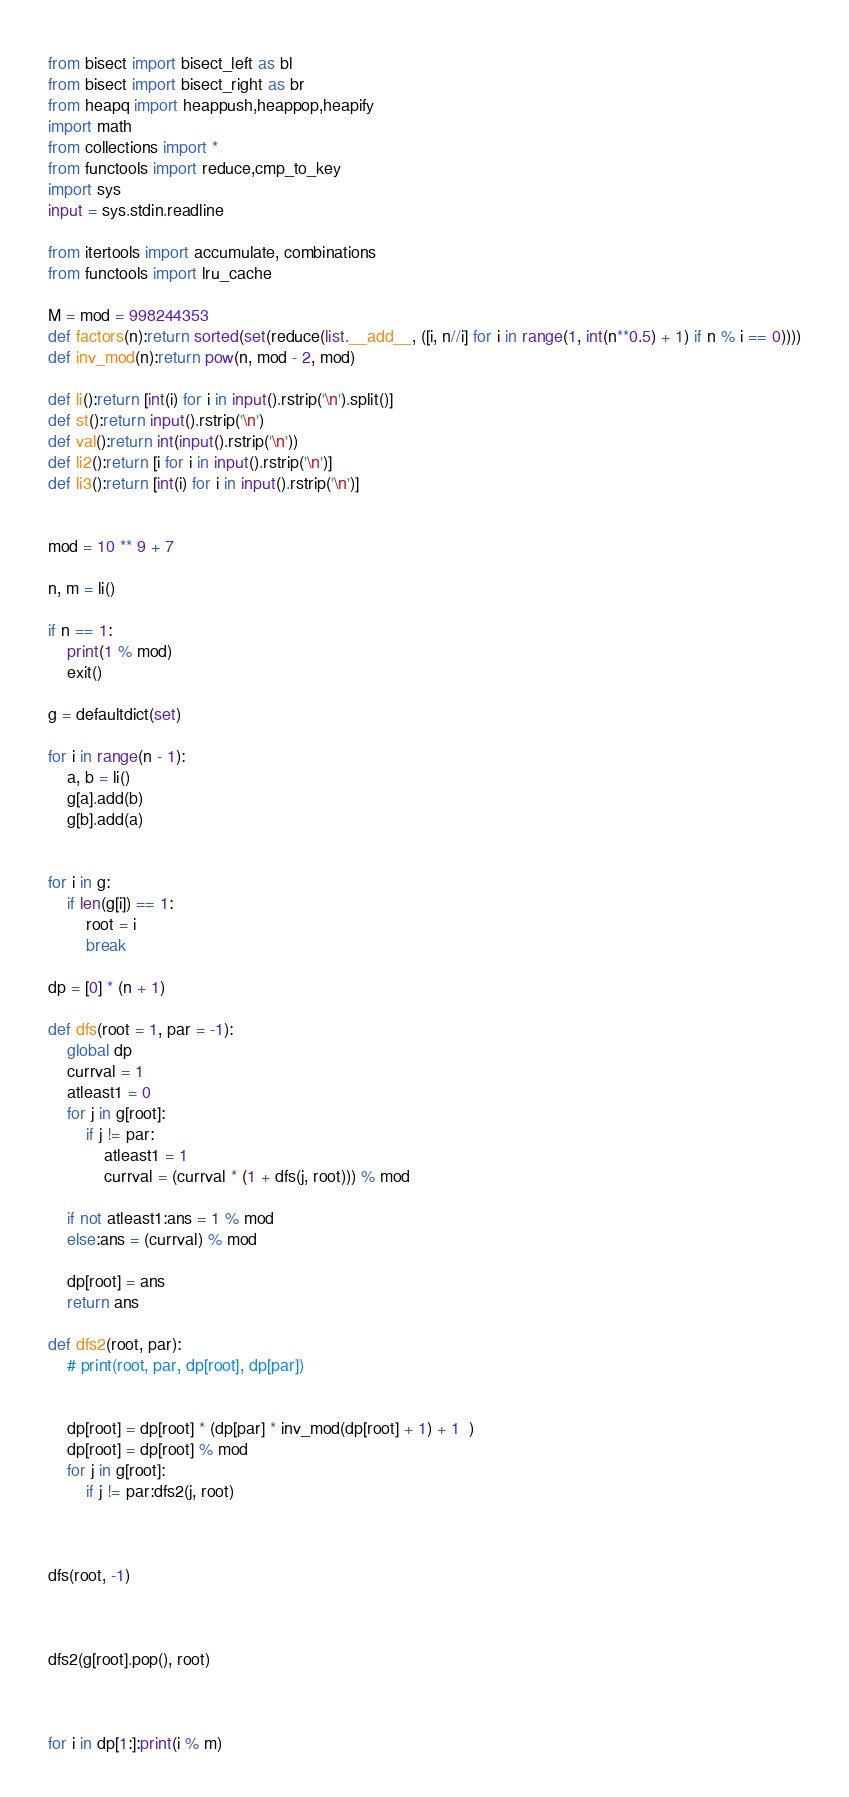Convert code to text. <code><loc_0><loc_0><loc_500><loc_500><_Python_>from bisect import bisect_left as bl
from bisect import bisect_right as br
from heapq import heappush,heappop,heapify
import math
from collections import *
from functools import reduce,cmp_to_key
import sys
input = sys.stdin.readline

from itertools import accumulate, combinations
from functools import lru_cache

M = mod = 998244353
def factors(n):return sorted(set(reduce(list.__add__, ([i, n//i] for i in range(1, int(n**0.5) + 1) if n % i == 0))))
def inv_mod(n):return pow(n, mod - 2, mod)

def li():return [int(i) for i in input().rstrip('\n').split()]
def st():return input().rstrip('\n')
def val():return int(input().rstrip('\n'))
def li2():return [i for i in input().rstrip('\n')]
def li3():return [int(i) for i in input().rstrip('\n')]


mod = 10 ** 9 + 7

n, m = li()

if n == 1:
    print(1 % mod)
    exit()

g = defaultdict(set)

for i in range(n - 1):
    a, b = li()
    g[a].add(b)
    g[b].add(a)


for i in g:
    if len(g[i]) == 1:
        root = i
        break

dp = [0] * (n + 1)

def dfs(root = 1, par = -1):
    global dp
    currval = 1
    atleast1 = 0
    for j in g[root]:
        if j != par:
            atleast1 = 1
            currval = (currval * (1 + dfs(j, root))) % mod
    
    if not atleast1:ans = 1 % mod
    else:ans = (currval) % mod

    dp[root] = ans
    return ans

def dfs2(root, par):
    # print(root, par, dp[root], dp[par])


    dp[root] = dp[root] * (dp[par] * inv_mod(dp[root] + 1) + 1  )
    dp[root] = dp[root] % mod
    for j in g[root]:
        if j != par:dfs2(j, root)



dfs(root, -1)



dfs2(g[root].pop(), root)



for i in dp[1:]:print(i % m)</code> 